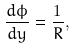Convert formula to latex. <formula><loc_0><loc_0><loc_500><loc_500>\frac { d \phi } { d y } = \frac { 1 } { R } ,</formula> 